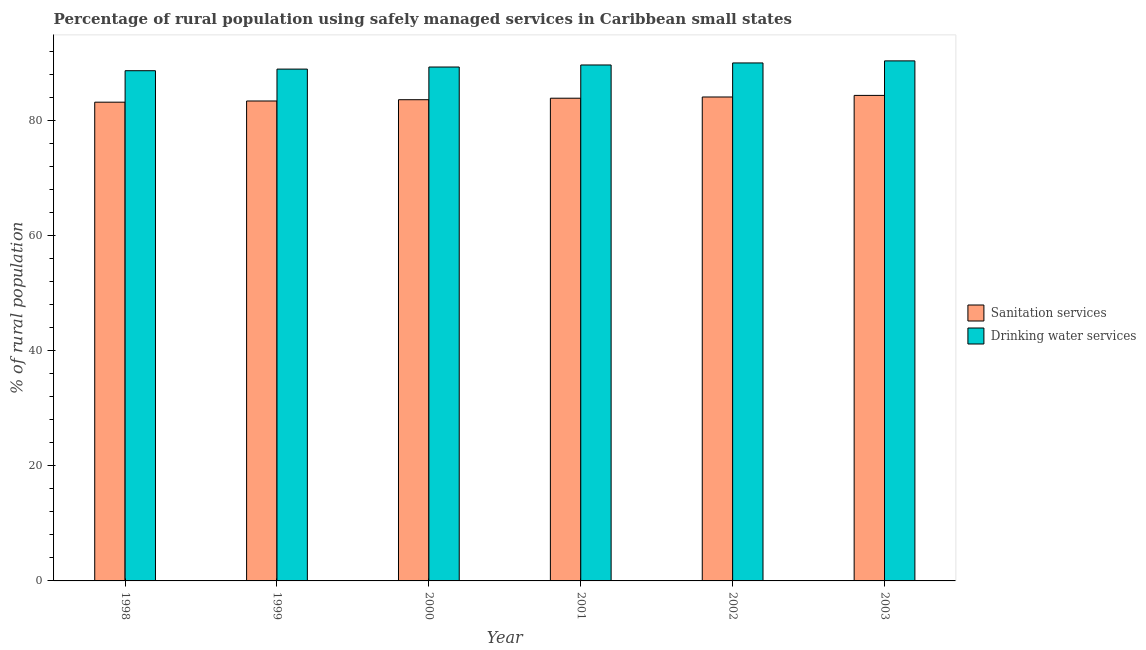Are the number of bars per tick equal to the number of legend labels?
Give a very brief answer. Yes. Are the number of bars on each tick of the X-axis equal?
Provide a short and direct response. Yes. What is the label of the 6th group of bars from the left?
Your response must be concise. 2003. What is the percentage of rural population who used sanitation services in 2001?
Keep it short and to the point. 83.93. Across all years, what is the maximum percentage of rural population who used sanitation services?
Give a very brief answer. 84.42. Across all years, what is the minimum percentage of rural population who used drinking water services?
Offer a very short reply. 88.71. What is the total percentage of rural population who used sanitation services in the graph?
Provide a succinct answer. 502.85. What is the difference between the percentage of rural population who used drinking water services in 1999 and that in 2000?
Your answer should be very brief. -0.36. What is the difference between the percentage of rural population who used drinking water services in 1998 and the percentage of rural population who used sanitation services in 1999?
Your response must be concise. -0.28. What is the average percentage of rural population who used drinking water services per year?
Ensure brevity in your answer.  89.54. What is the ratio of the percentage of rural population who used drinking water services in 2001 to that in 2003?
Your answer should be very brief. 0.99. Is the percentage of rural population who used drinking water services in 2001 less than that in 2002?
Provide a succinct answer. Yes. What is the difference between the highest and the second highest percentage of rural population who used drinking water services?
Provide a succinct answer. 0.36. What is the difference between the highest and the lowest percentage of rural population who used drinking water services?
Give a very brief answer. 1.71. In how many years, is the percentage of rural population who used sanitation services greater than the average percentage of rural population who used sanitation services taken over all years?
Offer a terse response. 3. What does the 2nd bar from the left in 2002 represents?
Give a very brief answer. Drinking water services. What does the 1st bar from the right in 2002 represents?
Give a very brief answer. Drinking water services. How many bars are there?
Give a very brief answer. 12. Are all the bars in the graph horizontal?
Your answer should be very brief. No. How many years are there in the graph?
Your answer should be compact. 6. What is the difference between two consecutive major ticks on the Y-axis?
Make the answer very short. 20. Are the values on the major ticks of Y-axis written in scientific E-notation?
Ensure brevity in your answer.  No. How many legend labels are there?
Offer a terse response. 2. What is the title of the graph?
Your answer should be compact. Percentage of rural population using safely managed services in Caribbean small states. What is the label or title of the X-axis?
Give a very brief answer. Year. What is the label or title of the Y-axis?
Give a very brief answer. % of rural population. What is the % of rural population in Sanitation services in 1998?
Your response must be concise. 83.24. What is the % of rural population of Drinking water services in 1998?
Offer a terse response. 88.71. What is the % of rural population in Sanitation services in 1999?
Keep it short and to the point. 83.45. What is the % of rural population in Drinking water services in 1999?
Give a very brief answer. 88.99. What is the % of rural population of Sanitation services in 2000?
Keep it short and to the point. 83.67. What is the % of rural population in Drinking water services in 2000?
Your answer should be very brief. 89.35. What is the % of rural population of Sanitation services in 2001?
Ensure brevity in your answer.  83.93. What is the % of rural population in Drinking water services in 2001?
Make the answer very short. 89.71. What is the % of rural population of Sanitation services in 2002?
Provide a succinct answer. 84.14. What is the % of rural population of Drinking water services in 2002?
Offer a very short reply. 90.06. What is the % of rural population of Sanitation services in 2003?
Keep it short and to the point. 84.42. What is the % of rural population of Drinking water services in 2003?
Offer a very short reply. 90.42. Across all years, what is the maximum % of rural population in Sanitation services?
Ensure brevity in your answer.  84.42. Across all years, what is the maximum % of rural population of Drinking water services?
Offer a very short reply. 90.42. Across all years, what is the minimum % of rural population in Sanitation services?
Provide a short and direct response. 83.24. Across all years, what is the minimum % of rural population of Drinking water services?
Make the answer very short. 88.71. What is the total % of rural population in Sanitation services in the graph?
Provide a succinct answer. 502.85. What is the total % of rural population of Drinking water services in the graph?
Your response must be concise. 537.25. What is the difference between the % of rural population of Sanitation services in 1998 and that in 1999?
Offer a very short reply. -0.21. What is the difference between the % of rural population of Drinking water services in 1998 and that in 1999?
Your answer should be very brief. -0.28. What is the difference between the % of rural population in Sanitation services in 1998 and that in 2000?
Your answer should be compact. -0.43. What is the difference between the % of rural population in Drinking water services in 1998 and that in 2000?
Provide a succinct answer. -0.64. What is the difference between the % of rural population in Sanitation services in 1998 and that in 2001?
Give a very brief answer. -0.69. What is the difference between the % of rural population of Drinking water services in 1998 and that in 2001?
Your answer should be compact. -1. What is the difference between the % of rural population of Sanitation services in 1998 and that in 2002?
Provide a short and direct response. -0.9. What is the difference between the % of rural population of Drinking water services in 1998 and that in 2002?
Your response must be concise. -1.35. What is the difference between the % of rural population in Sanitation services in 1998 and that in 2003?
Offer a terse response. -1.18. What is the difference between the % of rural population of Drinking water services in 1998 and that in 2003?
Offer a terse response. -1.71. What is the difference between the % of rural population of Sanitation services in 1999 and that in 2000?
Your answer should be very brief. -0.22. What is the difference between the % of rural population in Drinking water services in 1999 and that in 2000?
Your response must be concise. -0.36. What is the difference between the % of rural population of Sanitation services in 1999 and that in 2001?
Keep it short and to the point. -0.48. What is the difference between the % of rural population in Drinking water services in 1999 and that in 2001?
Make the answer very short. -0.72. What is the difference between the % of rural population of Sanitation services in 1999 and that in 2002?
Your response must be concise. -0.69. What is the difference between the % of rural population in Drinking water services in 1999 and that in 2002?
Give a very brief answer. -1.07. What is the difference between the % of rural population of Sanitation services in 1999 and that in 2003?
Provide a succinct answer. -0.97. What is the difference between the % of rural population of Drinking water services in 1999 and that in 2003?
Your answer should be very brief. -1.43. What is the difference between the % of rural population of Sanitation services in 2000 and that in 2001?
Provide a succinct answer. -0.26. What is the difference between the % of rural population of Drinking water services in 2000 and that in 2001?
Your answer should be compact. -0.36. What is the difference between the % of rural population of Sanitation services in 2000 and that in 2002?
Keep it short and to the point. -0.47. What is the difference between the % of rural population in Drinking water services in 2000 and that in 2002?
Your response must be concise. -0.71. What is the difference between the % of rural population of Sanitation services in 2000 and that in 2003?
Your response must be concise. -0.75. What is the difference between the % of rural population of Drinking water services in 2000 and that in 2003?
Offer a very short reply. -1.07. What is the difference between the % of rural population of Sanitation services in 2001 and that in 2002?
Make the answer very short. -0.21. What is the difference between the % of rural population of Drinking water services in 2001 and that in 2002?
Your response must be concise. -0.35. What is the difference between the % of rural population in Sanitation services in 2001 and that in 2003?
Provide a short and direct response. -0.49. What is the difference between the % of rural population of Drinking water services in 2001 and that in 2003?
Provide a succinct answer. -0.71. What is the difference between the % of rural population in Sanitation services in 2002 and that in 2003?
Ensure brevity in your answer.  -0.28. What is the difference between the % of rural population in Drinking water services in 2002 and that in 2003?
Your answer should be compact. -0.36. What is the difference between the % of rural population of Sanitation services in 1998 and the % of rural population of Drinking water services in 1999?
Your answer should be compact. -5.75. What is the difference between the % of rural population in Sanitation services in 1998 and the % of rural population in Drinking water services in 2000?
Your answer should be very brief. -6.11. What is the difference between the % of rural population of Sanitation services in 1998 and the % of rural population of Drinking water services in 2001?
Provide a succinct answer. -6.47. What is the difference between the % of rural population in Sanitation services in 1998 and the % of rural population in Drinking water services in 2002?
Your answer should be very brief. -6.82. What is the difference between the % of rural population of Sanitation services in 1998 and the % of rural population of Drinking water services in 2003?
Offer a terse response. -7.18. What is the difference between the % of rural population in Sanitation services in 1999 and the % of rural population in Drinking water services in 2000?
Provide a short and direct response. -5.9. What is the difference between the % of rural population in Sanitation services in 1999 and the % of rural population in Drinking water services in 2001?
Your answer should be very brief. -6.26. What is the difference between the % of rural population of Sanitation services in 1999 and the % of rural population of Drinking water services in 2002?
Ensure brevity in your answer.  -6.61. What is the difference between the % of rural population of Sanitation services in 1999 and the % of rural population of Drinking water services in 2003?
Provide a short and direct response. -6.97. What is the difference between the % of rural population in Sanitation services in 2000 and the % of rural population in Drinking water services in 2001?
Offer a very short reply. -6.04. What is the difference between the % of rural population of Sanitation services in 2000 and the % of rural population of Drinking water services in 2002?
Offer a terse response. -6.39. What is the difference between the % of rural population of Sanitation services in 2000 and the % of rural population of Drinking water services in 2003?
Offer a very short reply. -6.75. What is the difference between the % of rural population in Sanitation services in 2001 and the % of rural population in Drinking water services in 2002?
Offer a terse response. -6.13. What is the difference between the % of rural population of Sanitation services in 2001 and the % of rural population of Drinking water services in 2003?
Make the answer very short. -6.49. What is the difference between the % of rural population of Sanitation services in 2002 and the % of rural population of Drinking water services in 2003?
Offer a very short reply. -6.28. What is the average % of rural population of Sanitation services per year?
Your answer should be very brief. 83.81. What is the average % of rural population in Drinking water services per year?
Offer a very short reply. 89.54. In the year 1998, what is the difference between the % of rural population in Sanitation services and % of rural population in Drinking water services?
Make the answer very short. -5.47. In the year 1999, what is the difference between the % of rural population of Sanitation services and % of rural population of Drinking water services?
Offer a terse response. -5.55. In the year 2000, what is the difference between the % of rural population of Sanitation services and % of rural population of Drinking water services?
Provide a short and direct response. -5.68. In the year 2001, what is the difference between the % of rural population of Sanitation services and % of rural population of Drinking water services?
Give a very brief answer. -5.78. In the year 2002, what is the difference between the % of rural population of Sanitation services and % of rural population of Drinking water services?
Your answer should be very brief. -5.92. In the year 2003, what is the difference between the % of rural population in Sanitation services and % of rural population in Drinking water services?
Provide a short and direct response. -6. What is the ratio of the % of rural population of Sanitation services in 1998 to that in 1999?
Provide a short and direct response. 1. What is the ratio of the % of rural population of Sanitation services in 1998 to that in 2000?
Keep it short and to the point. 0.99. What is the ratio of the % of rural population in Drinking water services in 1998 to that in 2000?
Offer a very short reply. 0.99. What is the ratio of the % of rural population of Drinking water services in 1998 to that in 2001?
Keep it short and to the point. 0.99. What is the ratio of the % of rural population in Sanitation services in 1998 to that in 2002?
Ensure brevity in your answer.  0.99. What is the ratio of the % of rural population in Drinking water services in 1998 to that in 2003?
Offer a very short reply. 0.98. What is the ratio of the % of rural population in Drinking water services in 1999 to that in 2000?
Offer a terse response. 1. What is the ratio of the % of rural population of Drinking water services in 1999 to that in 2002?
Keep it short and to the point. 0.99. What is the ratio of the % of rural population in Sanitation services in 1999 to that in 2003?
Your answer should be compact. 0.99. What is the ratio of the % of rural population of Drinking water services in 1999 to that in 2003?
Give a very brief answer. 0.98. What is the ratio of the % of rural population in Sanitation services in 2000 to that in 2001?
Make the answer very short. 1. What is the ratio of the % of rural population in Drinking water services in 2000 to that in 2001?
Your answer should be very brief. 1. What is the ratio of the % of rural population in Sanitation services in 2000 to that in 2002?
Make the answer very short. 0.99. What is the ratio of the % of rural population in Sanitation services in 2000 to that in 2003?
Your answer should be compact. 0.99. What is the ratio of the % of rural population in Drinking water services in 2001 to that in 2002?
Make the answer very short. 1. What is the ratio of the % of rural population in Sanitation services in 2001 to that in 2003?
Offer a very short reply. 0.99. What is the difference between the highest and the second highest % of rural population of Sanitation services?
Ensure brevity in your answer.  0.28. What is the difference between the highest and the second highest % of rural population of Drinking water services?
Offer a terse response. 0.36. What is the difference between the highest and the lowest % of rural population in Sanitation services?
Your answer should be compact. 1.18. What is the difference between the highest and the lowest % of rural population of Drinking water services?
Provide a short and direct response. 1.71. 